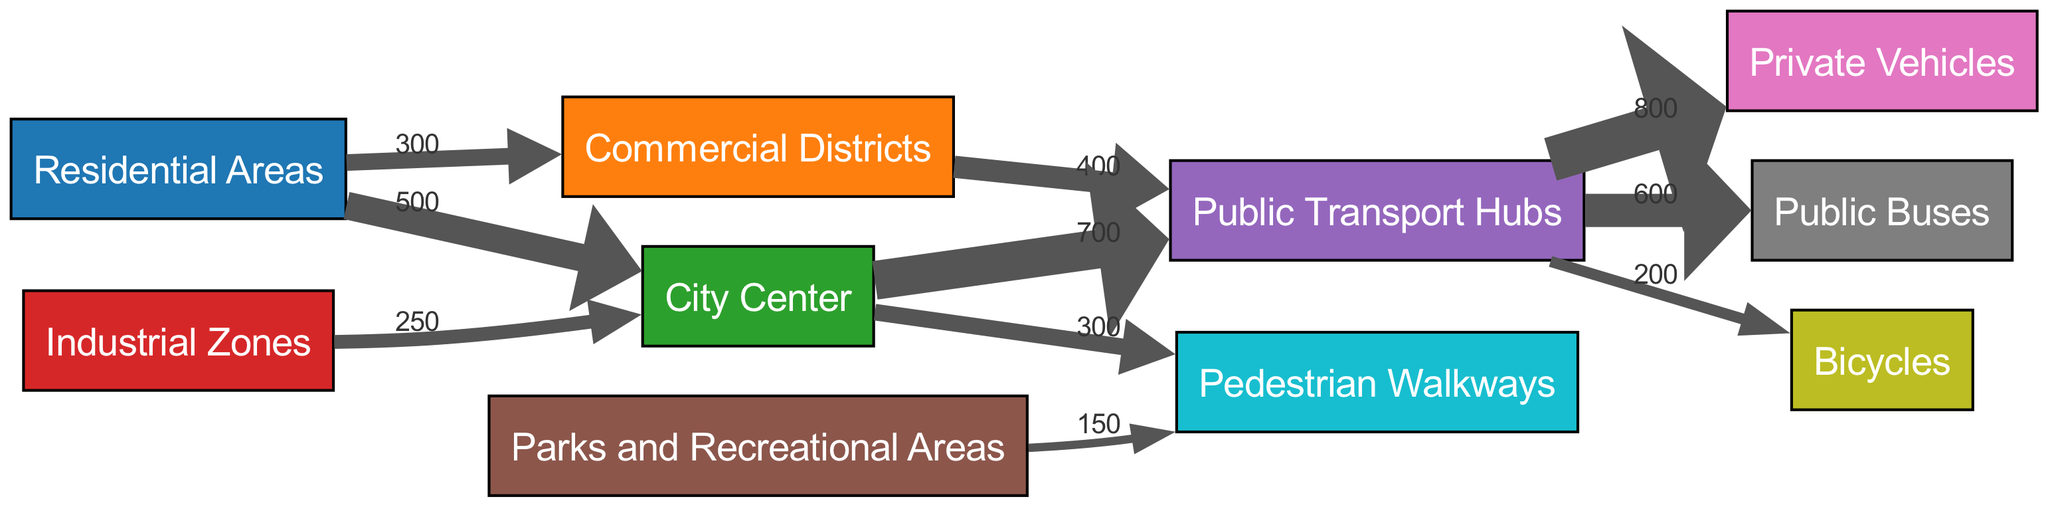What is the total traffic flow from Residential Areas to the City Center? The diagram indicates that the value representing the flow from Residential Areas to the City Center is explicitly labeled as 500.
Answer: 500 What is the flow value from the City Center to Public Transport Hubs? The link from the City Center to Public Transport Hubs shows a value of 700, which is noted on the edge of the link.
Answer: 700 How many nodes are present in the diagram? By counting the distinct entries under the nodes section in the data, there are 10 nodes listed.
Answer: 10 Which location has the highest traffic flow to Public Transport Hubs? The link from the City Center to Public Transport Hubs has the highest value at 700, indicating it has the most traffic flow directed to Public Transport Hubs.
Answer: City Center What is the total flow from Public Transport Hubs to all modes of transport? The total can be calculated by summing the values from Public Transport Hubs to Public Buses (600), Private Vehicles (800), and Bicycles (200). This results in a total flow of 600 + 800 + 200 = 1600.
Answer: 1600 Which origin has a direct flow to the Industrial Zones? Upon examining the diagram, there are no direct links indicating flow from any of the listed origins to Industrial Zones, thus it has no direct incoming links in the provided data.
Answer: None From which area do the most people transfer to Private Vehicles? The diagram indicates that the highest flow to Private Vehicles comes from Public Transport Hubs, with a value of 800 noted on that edge.
Answer: Public Transport Hubs What percentage of the flow from Residential Areas goes to Commercial Districts? The flow from Residential Areas to Commercial Districts is 300, while the total flow from Residential Areas is 800 (500 to City Center + 300 to Commercial Districts). The percentage is calculated as (300/800)*100 = 37.5%.
Answer: 37.5% What is the total flow leaving Public Transport Hubs? To find the total outgoing flow from Public Transport Hubs, we sum the outgoing values: to Public Buses (600), Private Vehicles (800), and Bicycles (200), giving us 600 + 800 + 200 = 1600.
Answer: 1600 